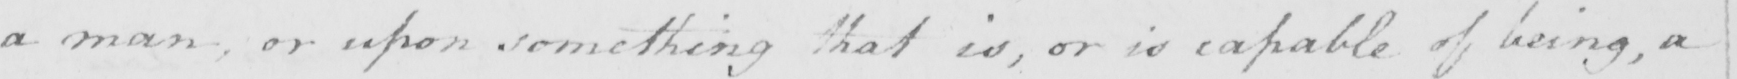Can you read and transcribe this handwriting? a man , or upon something that is , or is capable of being , a 